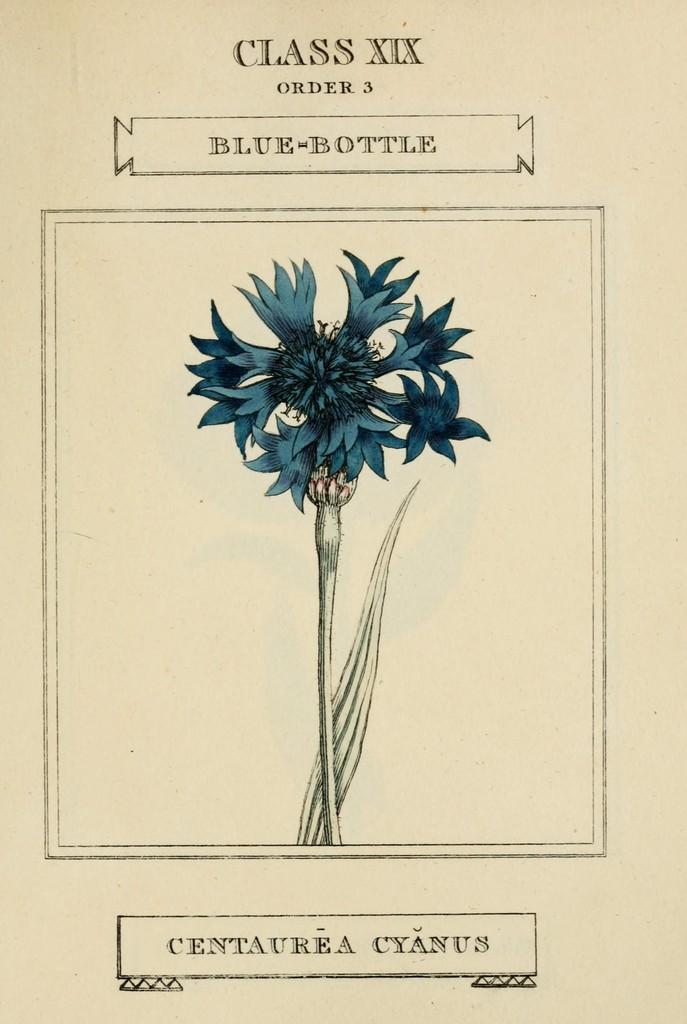Can you describe this image briefly? In this picture we can see a flower, leaf and some text. 